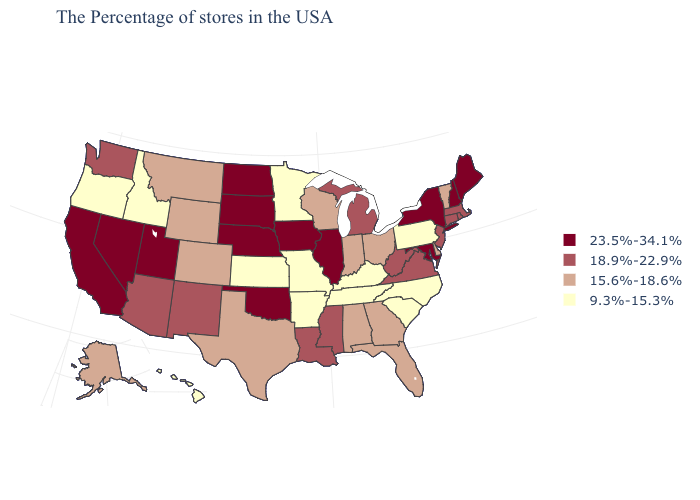How many symbols are there in the legend?
Concise answer only. 4. Does Nevada have the lowest value in the West?
Short answer required. No. Does the first symbol in the legend represent the smallest category?
Concise answer only. No. Among the states that border Washington , which have the highest value?
Write a very short answer. Idaho, Oregon. What is the value of Florida?
Give a very brief answer. 15.6%-18.6%. Name the states that have a value in the range 9.3%-15.3%?
Keep it brief. Pennsylvania, North Carolina, South Carolina, Kentucky, Tennessee, Missouri, Arkansas, Minnesota, Kansas, Idaho, Oregon, Hawaii. Name the states that have a value in the range 18.9%-22.9%?
Give a very brief answer. Massachusetts, Rhode Island, Connecticut, New Jersey, Virginia, West Virginia, Michigan, Mississippi, Louisiana, New Mexico, Arizona, Washington. Which states have the lowest value in the USA?
Give a very brief answer. Pennsylvania, North Carolina, South Carolina, Kentucky, Tennessee, Missouri, Arkansas, Minnesota, Kansas, Idaho, Oregon, Hawaii. What is the highest value in the West ?
Short answer required. 23.5%-34.1%. What is the value of Wisconsin?
Keep it brief. 15.6%-18.6%. What is the value of Texas?
Quick response, please. 15.6%-18.6%. Name the states that have a value in the range 23.5%-34.1%?
Short answer required. Maine, New Hampshire, New York, Maryland, Illinois, Iowa, Nebraska, Oklahoma, South Dakota, North Dakota, Utah, Nevada, California. Name the states that have a value in the range 18.9%-22.9%?
Be succinct. Massachusetts, Rhode Island, Connecticut, New Jersey, Virginia, West Virginia, Michigan, Mississippi, Louisiana, New Mexico, Arizona, Washington. 